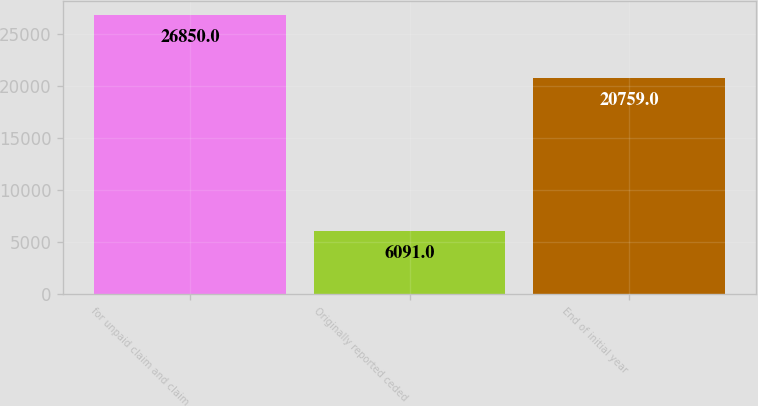Convert chart. <chart><loc_0><loc_0><loc_500><loc_500><bar_chart><fcel>for unpaid claim and claim<fcel>Originally reported ceded<fcel>End of initial year<nl><fcel>26850<fcel>6091<fcel>20759<nl></chart> 